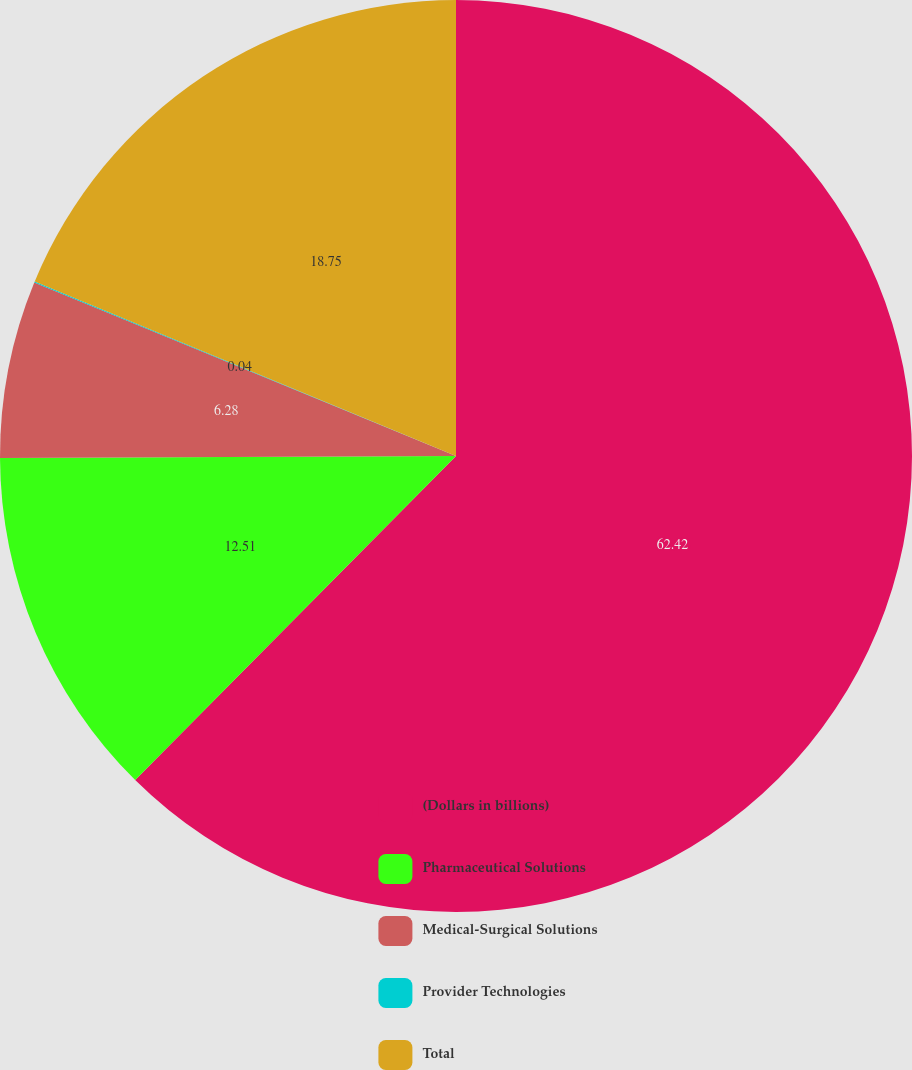<chart> <loc_0><loc_0><loc_500><loc_500><pie_chart><fcel>(Dollars in billions)<fcel>Pharmaceutical Solutions<fcel>Medical-Surgical Solutions<fcel>Provider Technologies<fcel>Total<nl><fcel>62.42%<fcel>12.51%<fcel>6.28%<fcel>0.04%<fcel>18.75%<nl></chart> 